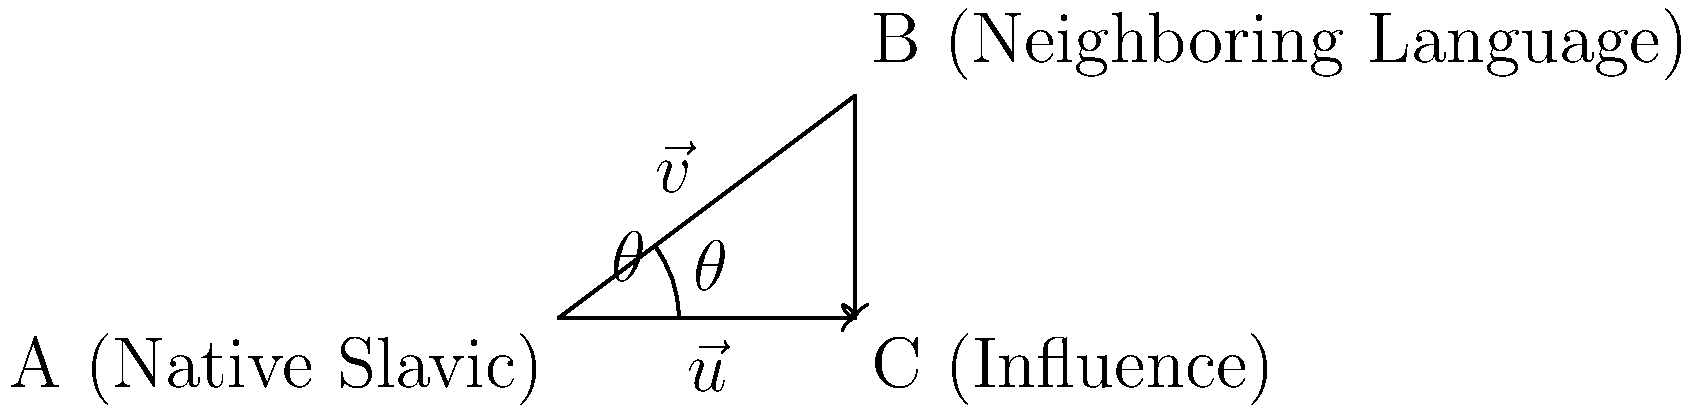In the diagram, vector $\vec{v}$ represents the linguistic features of a neighboring language, and vector $\vec{u}$ represents the influence of a native Slavic language. If $|\vec{v}| = 5$ and $|\vec{u}| = 4$, and the angle between them is $\theta = 36.87°$, calculate the magnitude of the projection of $\vec{v}$ onto $\vec{u}$. This projection represents the extent of influence the native Slavic language has on the neighboring language. To solve this problem, we'll use the formula for vector projection:

1) The formula for the magnitude of the projection of $\vec{v}$ onto $\vec{u}$ is:
   $$|\text{proj}_{\vec{u}}\vec{v}| = |\vec{v}| \cos\theta$$

2) We're given:
   $|\vec{v}| = 5$
   $|\vec{u}| = 4$ (not needed for this calculation)
   $\theta = 36.87°$

3) Let's substitute these values into our formula:
   $$|\text{proj}_{\vec{u}}\vec{v}| = 5 \cos(36.87°)$$

4) Now, we need to calculate $\cos(36.87°)$:
   $\cos(36.87°) \approx 0.8$$

5) Substituting this back into our equation:
   $$|\text{proj}_{\vec{u}}\vec{v}| = 5 * 0.8 = 4$$

Therefore, the magnitude of the projection of $\vec{v}$ onto $\vec{u}$ is 4.
Answer: 4 